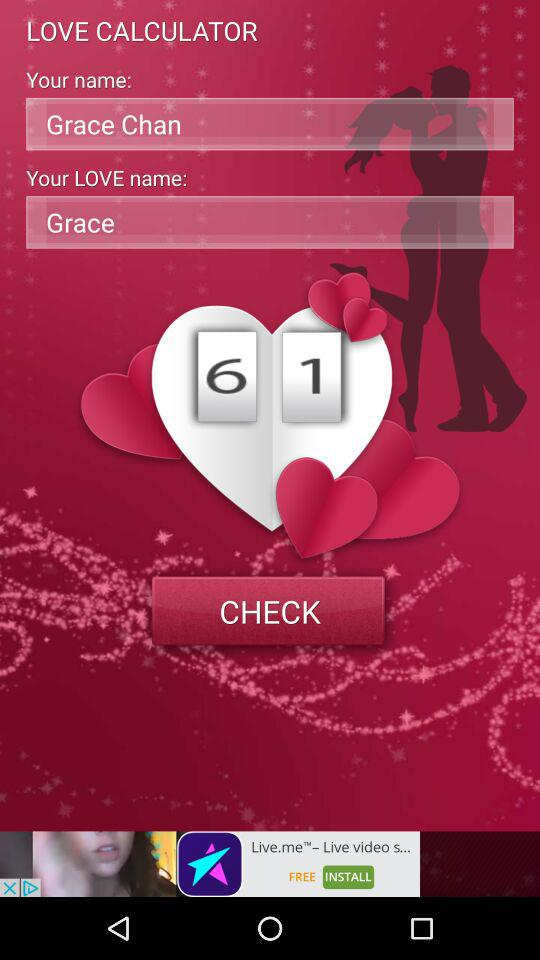What is the name of the user? The name of the user is Grace Chan. 